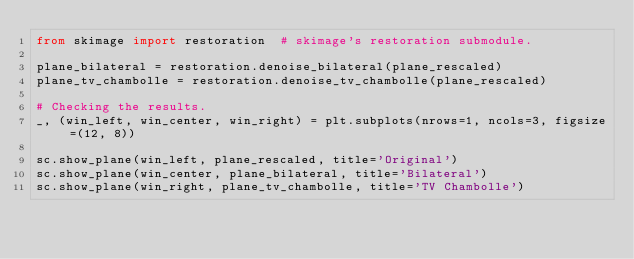<code> <loc_0><loc_0><loc_500><loc_500><_Python_>from skimage import restoration  # skimage's restoration submodule.

plane_bilateral = restoration.denoise_bilateral(plane_rescaled)
plane_tv_chambolle = restoration.denoise_tv_chambolle(plane_rescaled)

# Checking the results.
_, (win_left, win_center, win_right) = plt.subplots(nrows=1, ncols=3, figsize=(12, 8))

sc.show_plane(win_left, plane_rescaled, title='Original')
sc.show_plane(win_center, plane_bilateral, title='Bilateral')
sc.show_plane(win_right, plane_tv_chambolle, title='TV Chambolle')
</code> 